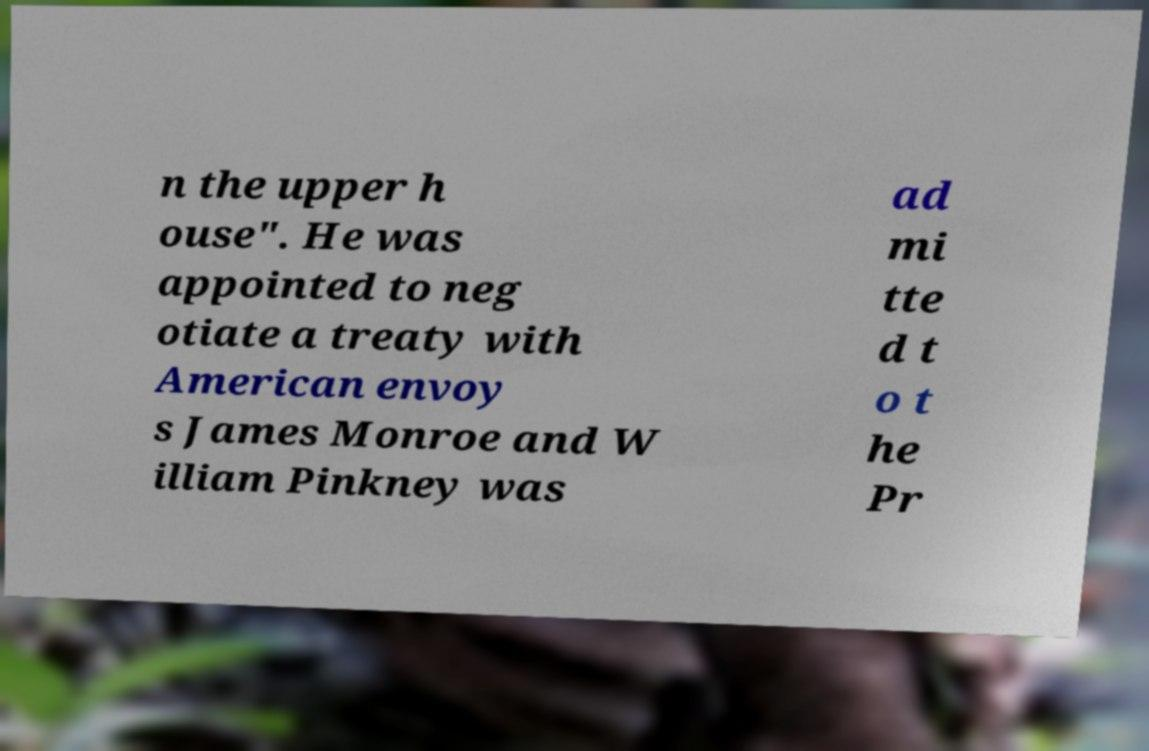Can you read and provide the text displayed in the image?This photo seems to have some interesting text. Can you extract and type it out for me? n the upper h ouse". He was appointed to neg otiate a treaty with American envoy s James Monroe and W illiam Pinkney was ad mi tte d t o t he Pr 